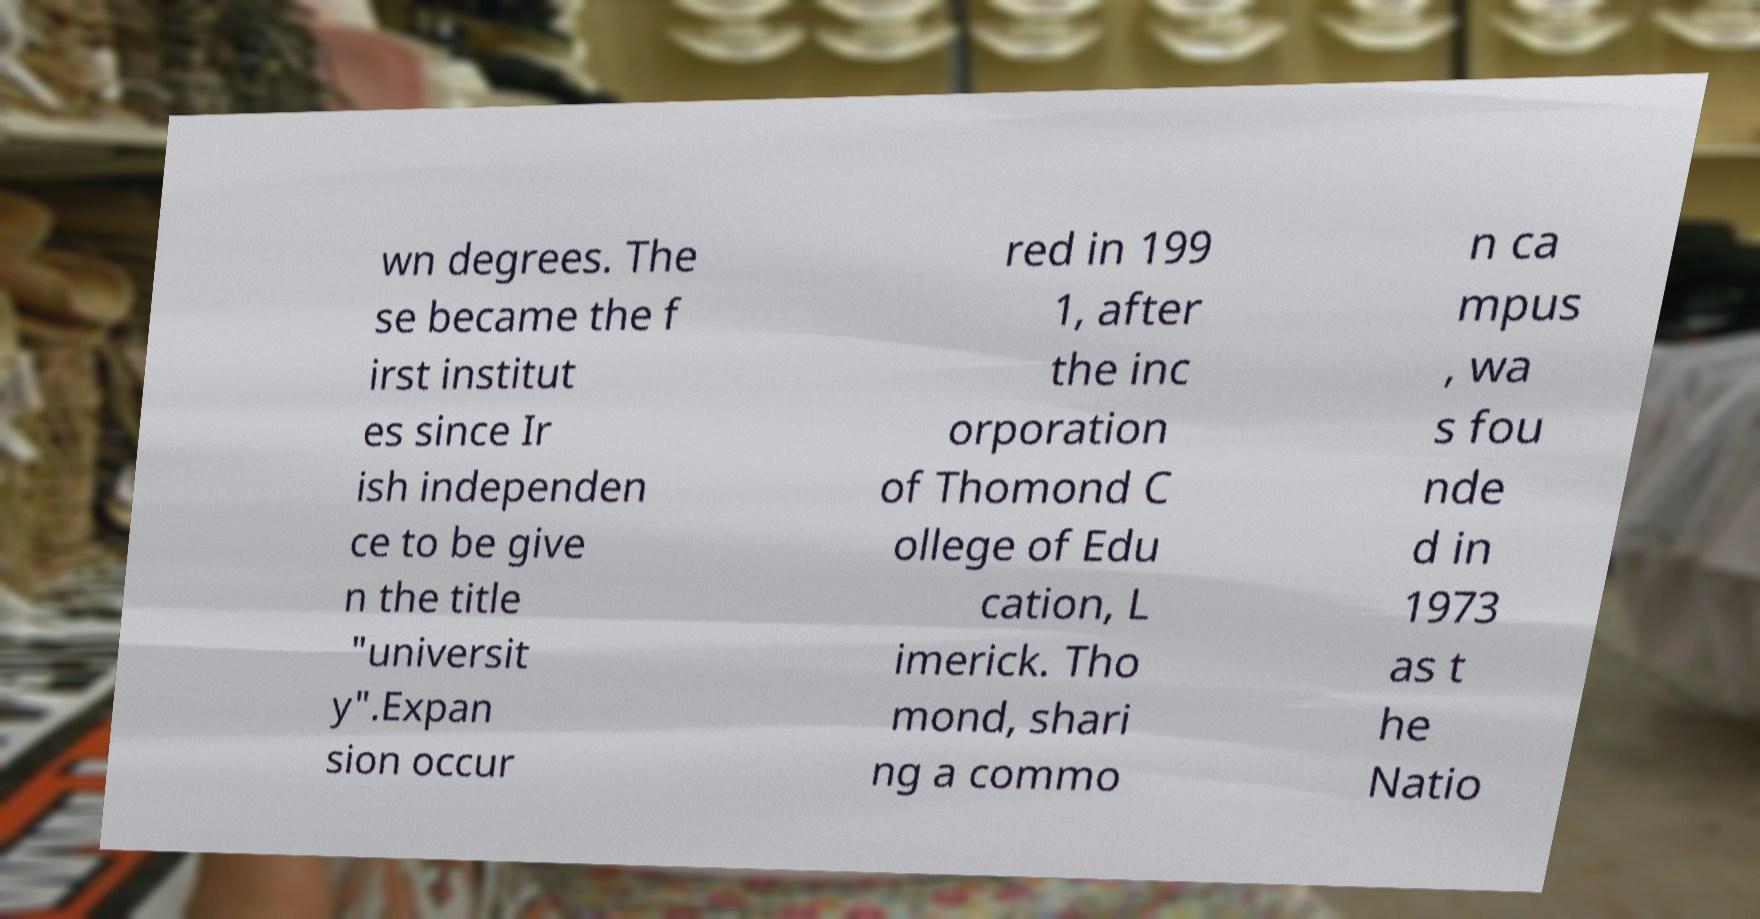Can you read and provide the text displayed in the image?This photo seems to have some interesting text. Can you extract and type it out for me? wn degrees. The se became the f irst institut es since Ir ish independen ce to be give n the title "universit y".Expan sion occur red in 199 1, after the inc orporation of Thomond C ollege of Edu cation, L imerick. Tho mond, shari ng a commo n ca mpus , wa s fou nde d in 1973 as t he Natio 